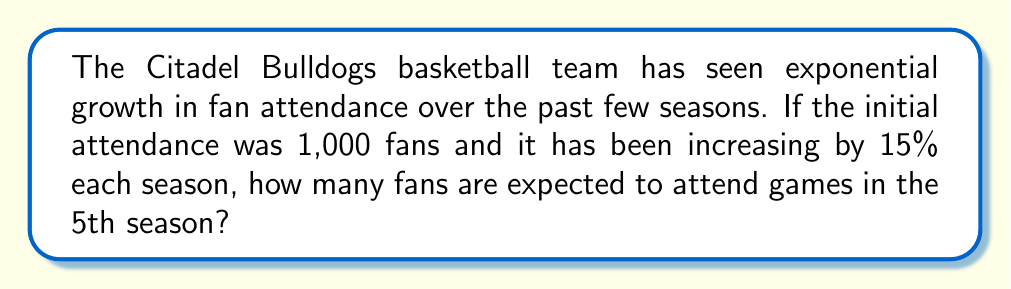Can you answer this question? Let's approach this step-by-step:

1) The initial attendance (season 0) is 1,000 fans.

2) The growth rate is 15% per season, which means we multiply by 1.15 each season.

3) We can represent this with the exponential function:
   $$A(t) = 1000 \cdot (1.15)^t$$
   where $A(t)$ is the attendance and $t$ is the number of seasons.

4) We want to know the attendance in the 5th season, so we plug in $t = 5$:
   $$A(5) = 1000 \cdot (1.15)^5$$

5) Let's calculate this:
   $$A(5) = 1000 \cdot 2.0113689$$
   
6) This gives us:
   $$A(5) = 2011.3689$$

7) Since we're dealing with people, we round to the nearest whole number:
   $$A(5) \approx 2011$$ fans
Answer: 2011 fans 